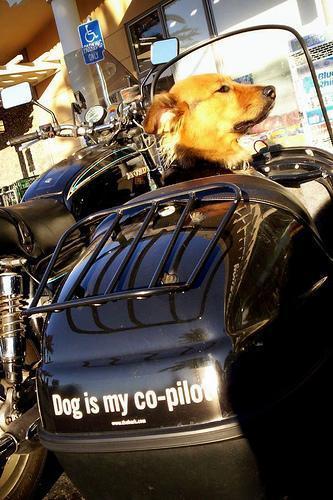How many motorcycles can be seen?
Give a very brief answer. 2. How many chairs are under the wood board?
Give a very brief answer. 0. 